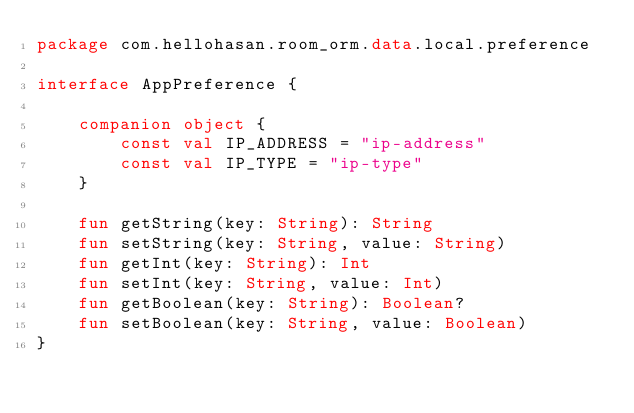Convert code to text. <code><loc_0><loc_0><loc_500><loc_500><_Kotlin_>package com.hellohasan.room_orm.data.local.preference

interface AppPreference {

    companion object {
        const val IP_ADDRESS = "ip-address"
        const val IP_TYPE = "ip-type"
    }

    fun getString(key: String): String
    fun setString(key: String, value: String)
    fun getInt(key: String): Int
    fun setInt(key: String, value: Int)
    fun getBoolean(key: String): Boolean?
    fun setBoolean(key: String, value: Boolean)
}</code> 